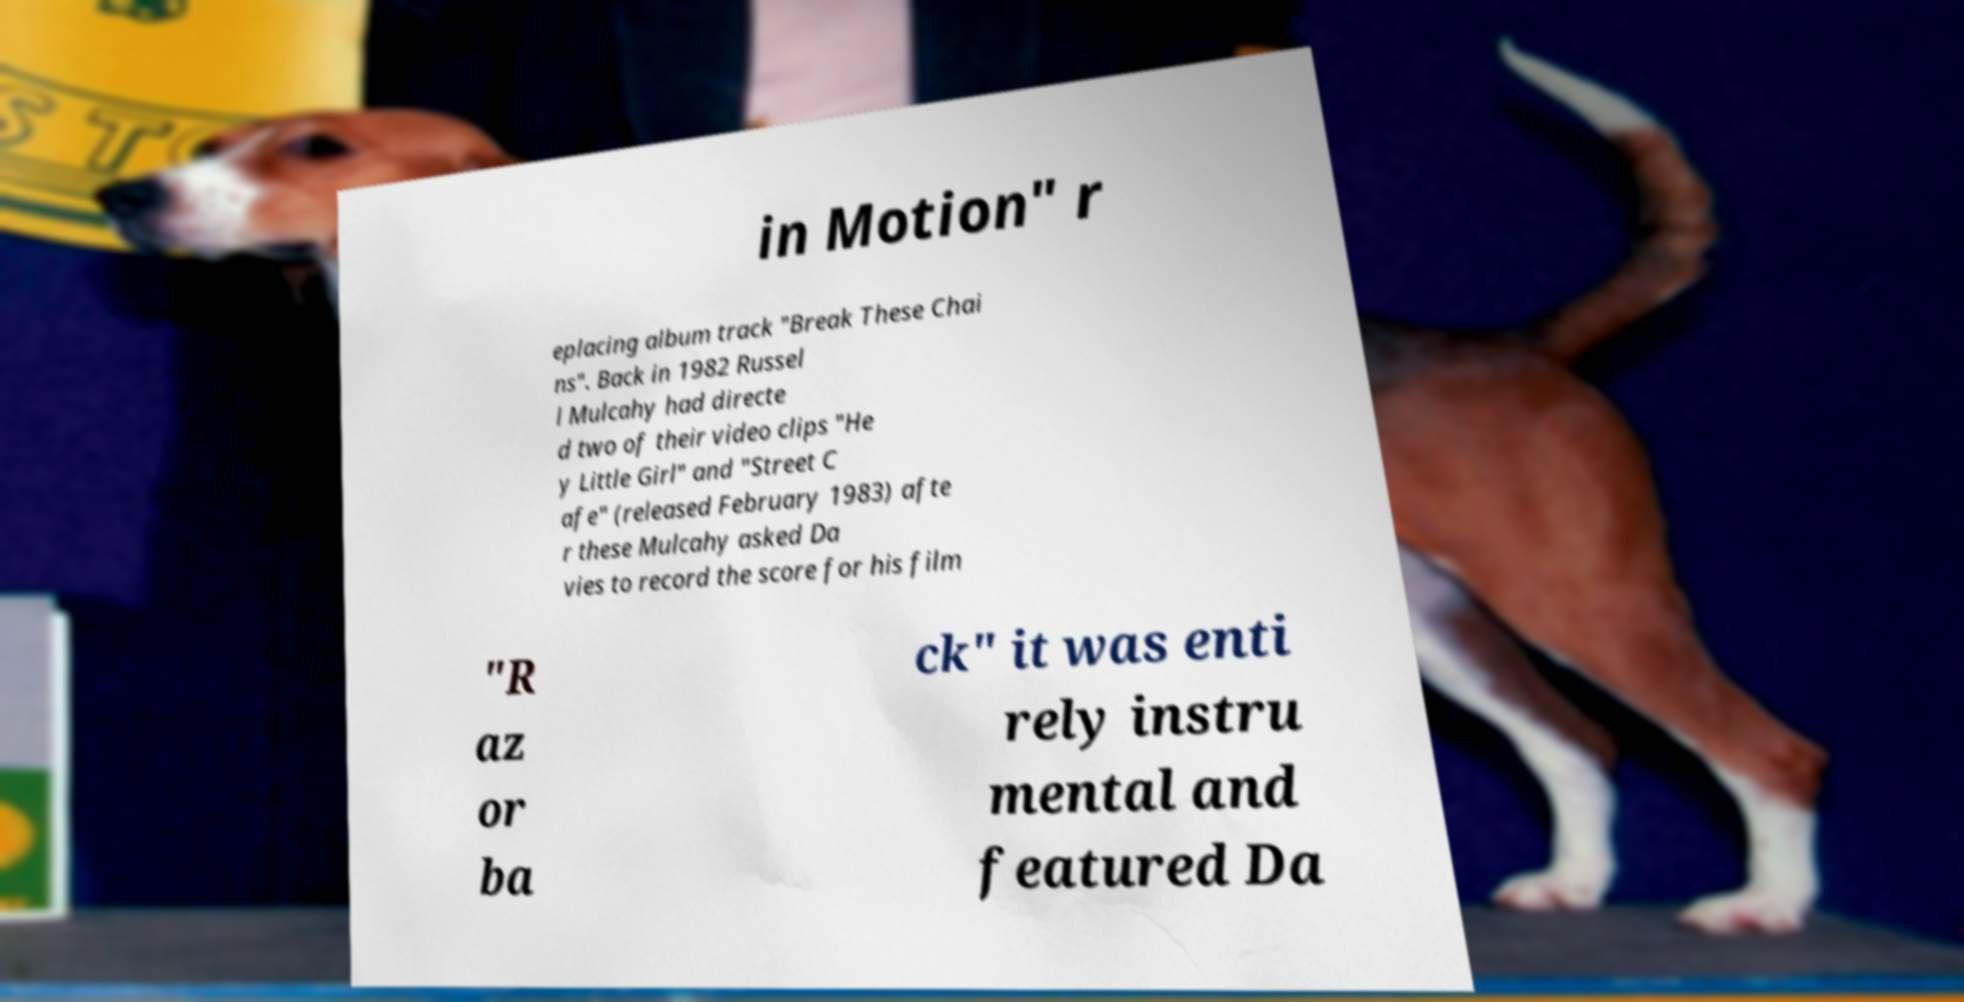There's text embedded in this image that I need extracted. Can you transcribe it verbatim? in Motion" r eplacing album track "Break These Chai ns". Back in 1982 Russel l Mulcahy had directe d two of their video clips "He y Little Girl" and "Street C afe" (released February 1983) afte r these Mulcahy asked Da vies to record the score for his film "R az or ba ck" it was enti rely instru mental and featured Da 